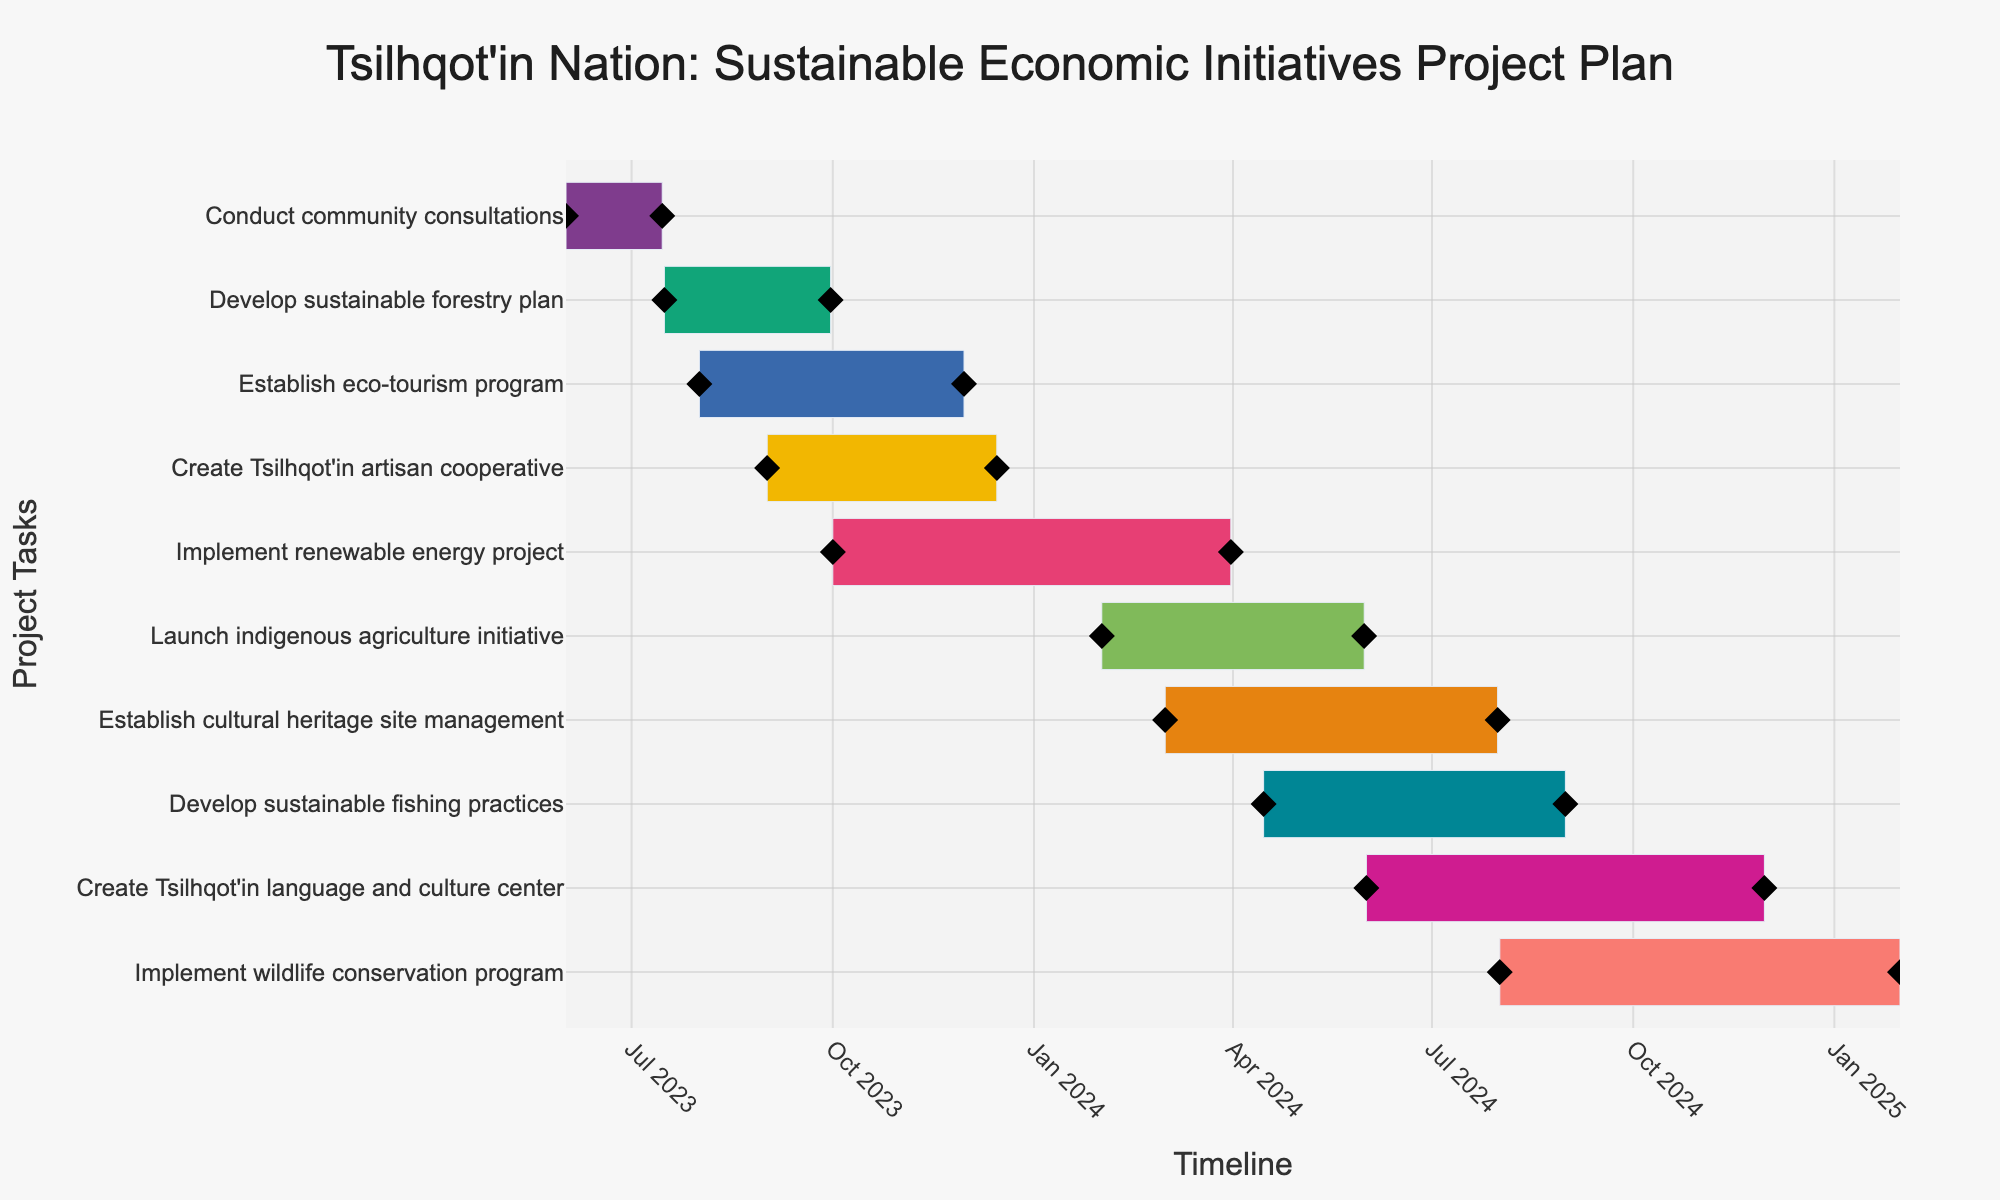What is the title of the Gantt chart? The title of the Gantt chart is usually displayed at the top of the figure in a larger font size. From the plot code, the title specified is "Tsilhqot'in Nation: Sustainable Economic Initiatives Project Plan".
Answer: Tsilhqot'in Nation: Sustainable Economic Initiatives Project Plan How many tasks are included in the project plan? Each task is represented as a distinct bar in the Gantt chart, listed on the y-axis. By counting the tasks, we see there are 10 tasks.
Answer: 10 Which task has the longest duration? The duration of each task is shown as the length of the bars. We can compare the bars to see that the "Implement wildlife conservation program" task has the longest bar, indicating the longest duration.
Answer: Implement wildlife conservation program When does the "Create Tsilhqot'in language and culture center" task start and end? To find this information, we locate the bar for the "Create Tsilhqot'in language and culture center" task and look at the start and end points along the x-axis. The start date is June 1, 2024, and the end date is November 30, 2024.
Answer: June 1, 2024 to November 30, 2024 How many tasks are planned to start in 2024? We need to identify the tasks that begin in the calendar year 2024 by looking at the start dates along the x-axis for each task. There are four tasks: "Launch indigenous agriculture initiative", "Establish cultural heritage site management", "Develop sustainable fishing practices", and "Create Tsilhqot'in language and culture center".
Answer: 4 Which task overlaps with the "Develop sustainable forestry plan"? To determine which tasks overlap, we look at tasks that have any part of their bar within the range of the "Develop sustainable forestry plan" bar which starts on July 16, 2023, and ends on September 30, 2023. The "Establish eco-tourism program" (Aug 1, 2023 - Nov 30, 2023) overlaps with it.
Answer: Establish eco-tourism program Compare the duration between "Establish eco-tourism program" and "Create Tsilhqot'in artisan cooperative". Which one has a longer duration? We compare the lengths of the two bars to determine durations. "Establish eco-tourism program" has a duration of 122 days, while "Create Tsilhqot'in artisan cooperative" has a duration of 106 days. Therefore, the "Establish eco-tourism program" has a longer duration.
Answer: Establish eco-tourism program What is the total project timeline from the start of the first task to the end of the last task? To find the overall project timeline, we look at the earliest start date and the latest end date. The first task starts on June 1, 2023, and the last task ends on January 31, 2025.
Answer: June 1, 2023 to January 31, 2025 